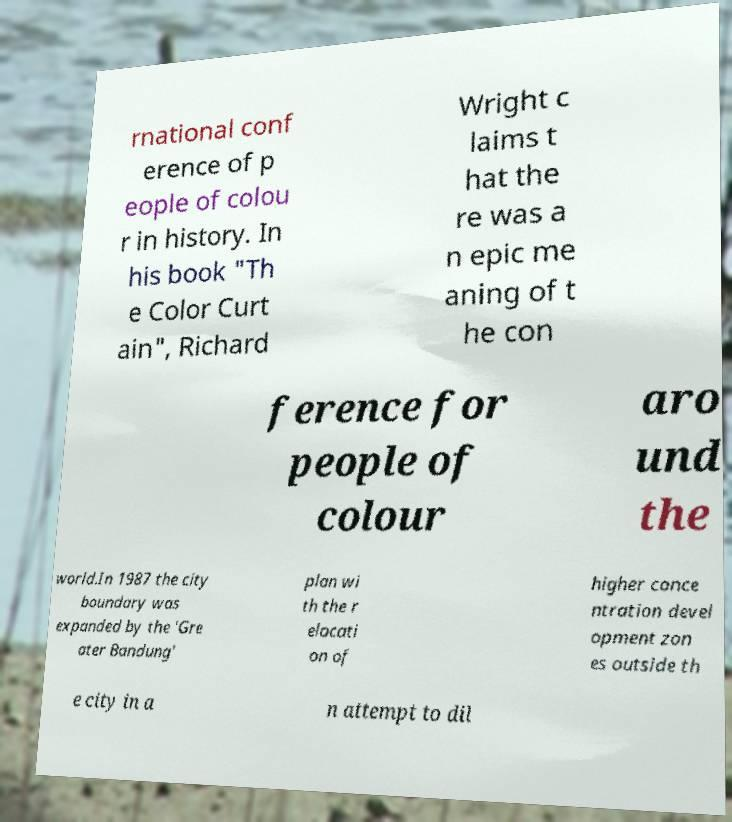Please identify and transcribe the text found in this image. rnational conf erence of p eople of colou r in history. In his book "Th e Color Curt ain", Richard Wright c laims t hat the re was a n epic me aning of t he con ference for people of colour aro und the world.In 1987 the city boundary was expanded by the 'Gre ater Bandung' plan wi th the r elocati on of higher conce ntration devel opment zon es outside th e city in a n attempt to dil 